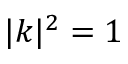Convert formula to latex. <formula><loc_0><loc_0><loc_500><loc_500>| \boldsymbol k | ^ { 2 } = 1</formula> 